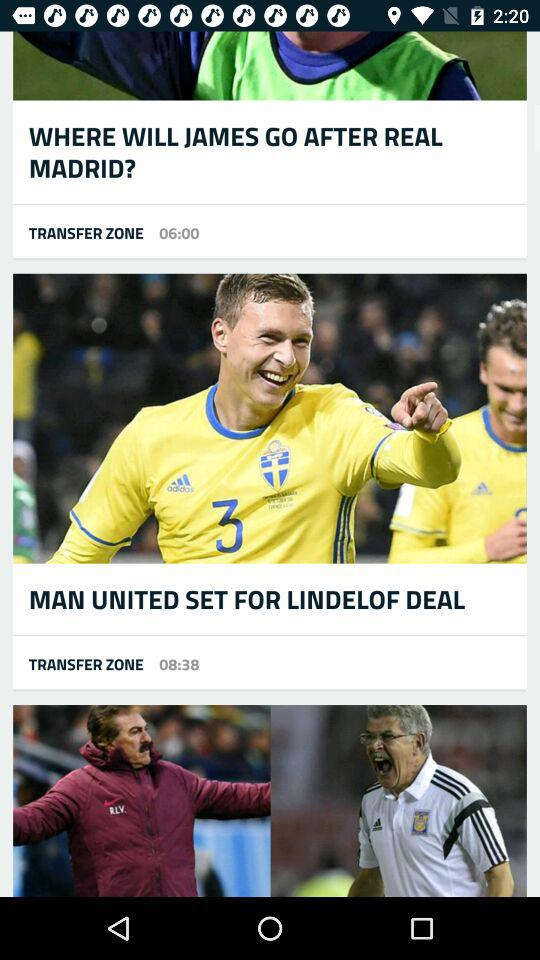At what time was the news about James posted by "TRANSFER ZONE"? The news about James was posted by "TRANSFER ZONE" at 06:00. 